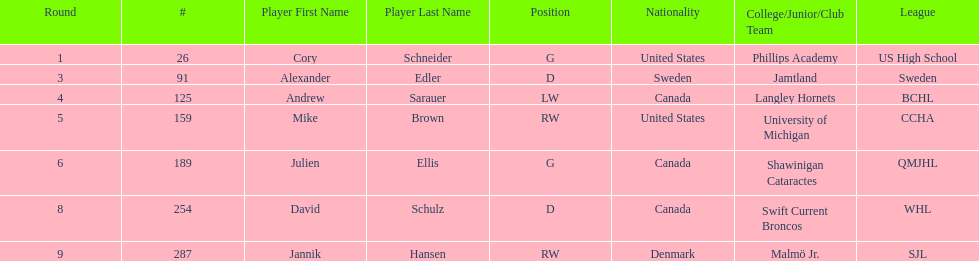How many players were from the united states? 2. 